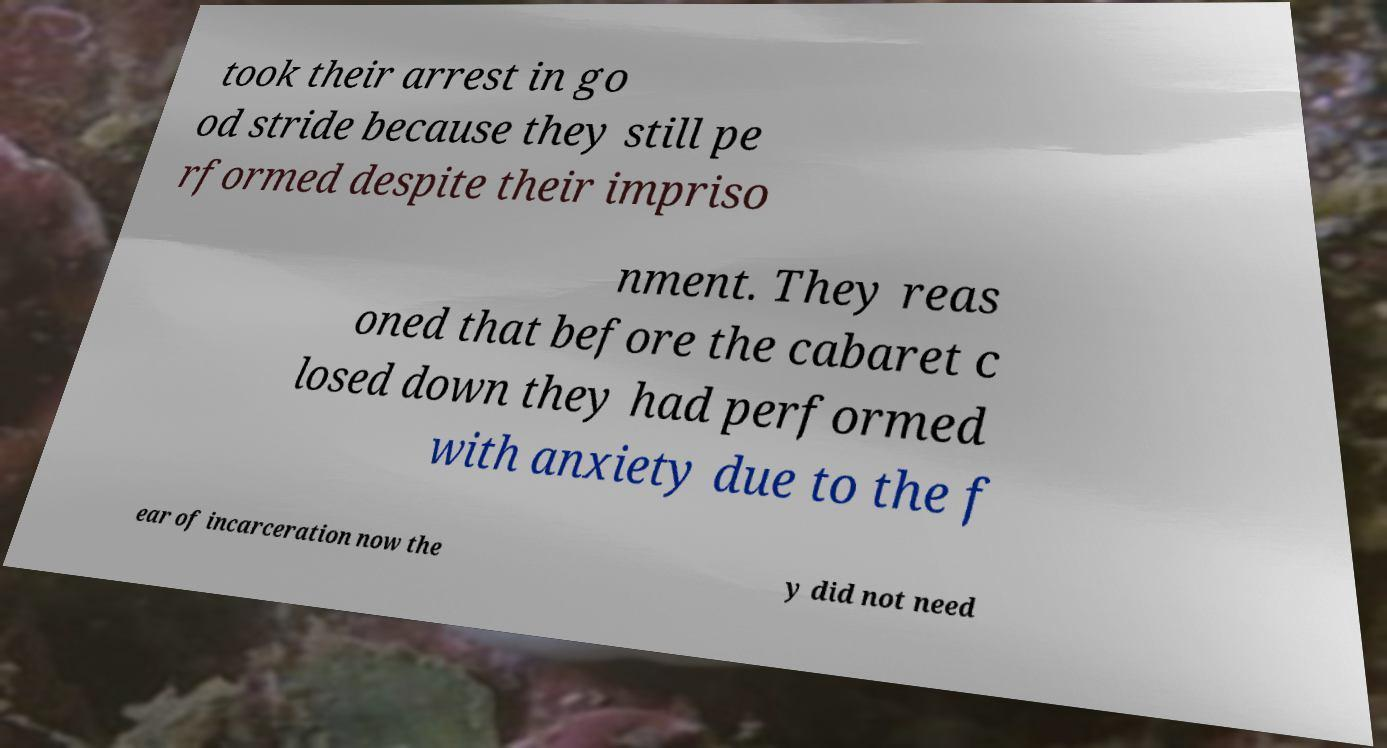Could you extract and type out the text from this image? took their arrest in go od stride because they still pe rformed despite their impriso nment. They reas oned that before the cabaret c losed down they had performed with anxiety due to the f ear of incarceration now the y did not need 